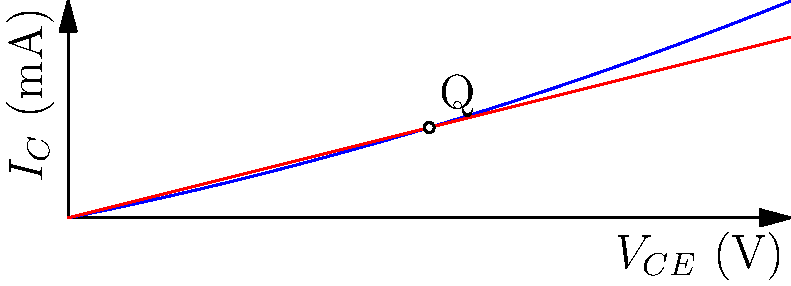Based on the characteristic curves shown in the graph, determine the small-signal voltage gain ($A_v$) of the common-emitter amplifier at the Q-point. Assume the Early voltage ($V_A$) is 100V and the load resistance ($R_L$) is 4k$\Omega$. To find the small-signal voltage gain, we need to follow these steps:

1) Identify the Q-point: From the graph, we can see that $V_{CE} \approx 5V$ and $I_C \approx 1.25mA$ at the Q-point.

2) Calculate the transconductance ($g_m$):
   $g_m = \frac{I_C}{V_T}$, where $V_T = 26mV$ at room temperature
   $g_m = \frac{1.25mA}{26mV} = 48.08mS$

3) Calculate the output resistance ($r_o$):
   $r_o = \frac{V_A}{I_C} = \frac{100V}{1.25mA} = 80k\Omega$

4) The small-signal voltage gain is given by:
   $A_v = -g_m(R_L || r_o)$

5) Calculate $R_L || r_o$:
   $R_L || r_o = \frac{R_L \cdot r_o}{R_L + r_o} = \frac{4k\Omega \cdot 80k\Omega}{4k\Omega + 80k\Omega} = 3.81k\Omega$

6) Finally, calculate $A_v$:
   $A_v = -48.08mS \cdot 3.81k\Omega = -183.18$

The negative sign indicates a 180-degree phase shift, which is characteristic of common-emitter amplifiers.
Answer: $A_v = -183.18$ 